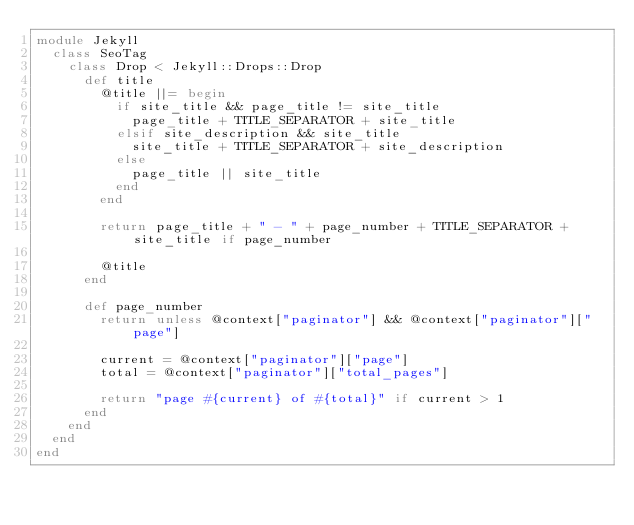<code> <loc_0><loc_0><loc_500><loc_500><_Ruby_>module Jekyll
  class SeoTag
    class Drop < Jekyll::Drops::Drop
      def title
        @title ||= begin
          if site_title && page_title != site_title
            page_title + TITLE_SEPARATOR + site_title
          elsif site_description && site_title
            site_title + TITLE_SEPARATOR + site_description
          else
            page_title || site_title
          end
        end

        return page_title + " - " + page_number + TITLE_SEPARATOR + site_title if page_number

        @title
      end

      def page_number
        return unless @context["paginator"] && @context["paginator"]["page"]

        current = @context["paginator"]["page"]
        total = @context["paginator"]["total_pages"]

        return "page #{current} of #{total}" if current > 1
      end
    end
  end
end
</code> 